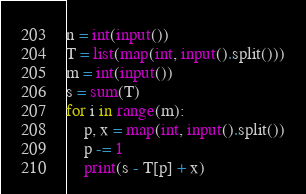<code> <loc_0><loc_0><loc_500><loc_500><_Python_>n = int(input())
T = list(map(int, input().split()))
m = int(input())
s = sum(T)
for i in range(m):
	p, x = map(int, input().split())
	p -= 1
	print(s - T[p] + x)</code> 